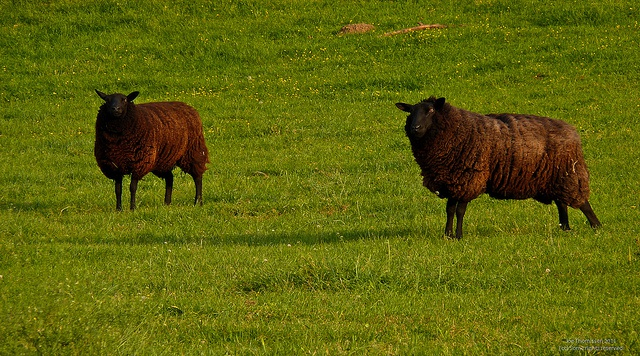Describe the objects in this image and their specific colors. I can see sheep in darkgreen, black, maroon, olive, and brown tones and sheep in darkgreen, black, maroon, olive, and brown tones in this image. 